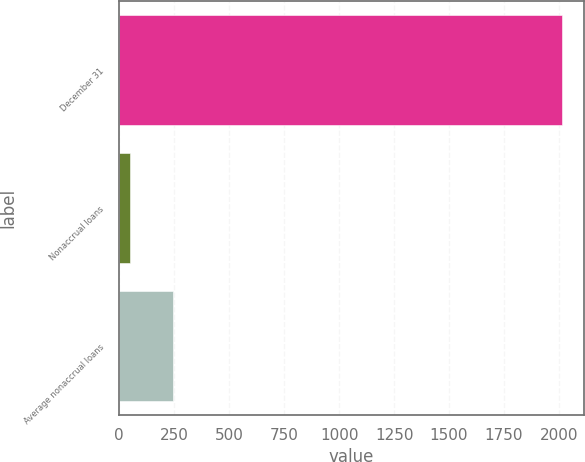Convert chart. <chart><loc_0><loc_0><loc_500><loc_500><bar_chart><fcel>December 31<fcel>Nonaccrual loans<fcel>Average nonaccrual loans<nl><fcel>2012<fcel>48<fcel>244.4<nl></chart> 